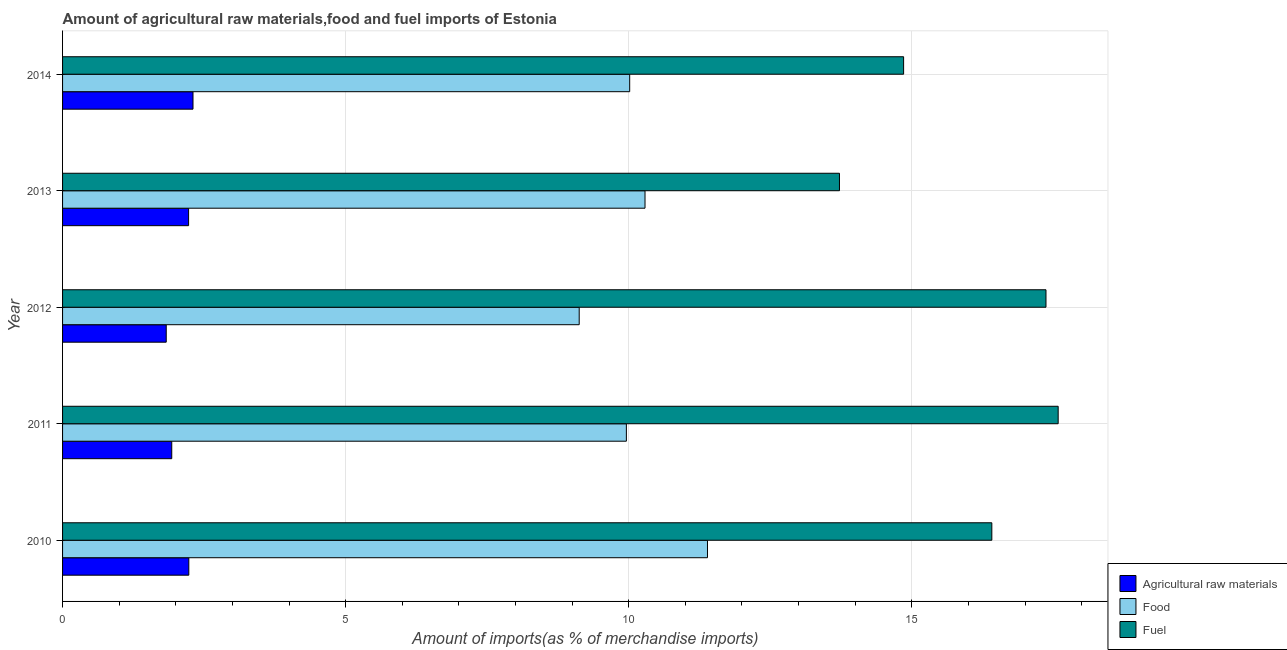Are the number of bars per tick equal to the number of legend labels?
Make the answer very short. Yes. Are the number of bars on each tick of the Y-axis equal?
Ensure brevity in your answer.  Yes. How many bars are there on the 2nd tick from the top?
Provide a short and direct response. 3. How many bars are there on the 5th tick from the bottom?
Your answer should be very brief. 3. What is the label of the 2nd group of bars from the top?
Offer a very short reply. 2013. In how many cases, is the number of bars for a given year not equal to the number of legend labels?
Offer a very short reply. 0. What is the percentage of food imports in 2013?
Your response must be concise. 10.29. Across all years, what is the maximum percentage of raw materials imports?
Give a very brief answer. 2.3. Across all years, what is the minimum percentage of raw materials imports?
Provide a succinct answer. 1.83. In which year was the percentage of fuel imports maximum?
Your response must be concise. 2011. In which year was the percentage of fuel imports minimum?
Ensure brevity in your answer.  2013. What is the total percentage of raw materials imports in the graph?
Keep it short and to the point. 10.52. What is the difference between the percentage of food imports in 2011 and that in 2012?
Your response must be concise. 0.83. What is the difference between the percentage of fuel imports in 2010 and the percentage of food imports in 2013?
Your answer should be compact. 6.13. What is the average percentage of food imports per year?
Give a very brief answer. 10.16. In the year 2011, what is the difference between the percentage of fuel imports and percentage of food imports?
Provide a succinct answer. 7.63. Is the percentage of food imports in 2011 less than that in 2012?
Ensure brevity in your answer.  No. What is the difference between the highest and the second highest percentage of raw materials imports?
Give a very brief answer. 0.07. What is the difference between the highest and the lowest percentage of fuel imports?
Your answer should be very brief. 3.86. In how many years, is the percentage of food imports greater than the average percentage of food imports taken over all years?
Offer a very short reply. 2. What does the 3rd bar from the top in 2014 represents?
Ensure brevity in your answer.  Agricultural raw materials. What does the 2nd bar from the bottom in 2013 represents?
Keep it short and to the point. Food. Is it the case that in every year, the sum of the percentage of raw materials imports and percentage of food imports is greater than the percentage of fuel imports?
Provide a short and direct response. No. How many bars are there?
Your answer should be very brief. 15. Are the values on the major ticks of X-axis written in scientific E-notation?
Give a very brief answer. No. Does the graph contain grids?
Your response must be concise. Yes. How are the legend labels stacked?
Make the answer very short. Vertical. What is the title of the graph?
Make the answer very short. Amount of agricultural raw materials,food and fuel imports of Estonia. What is the label or title of the X-axis?
Offer a very short reply. Amount of imports(as % of merchandise imports). What is the label or title of the Y-axis?
Your response must be concise. Year. What is the Amount of imports(as % of merchandise imports) of Agricultural raw materials in 2010?
Give a very brief answer. 2.23. What is the Amount of imports(as % of merchandise imports) of Food in 2010?
Your answer should be very brief. 11.39. What is the Amount of imports(as % of merchandise imports) in Fuel in 2010?
Make the answer very short. 16.41. What is the Amount of imports(as % of merchandise imports) in Agricultural raw materials in 2011?
Your response must be concise. 1.93. What is the Amount of imports(as % of merchandise imports) of Food in 2011?
Keep it short and to the point. 9.96. What is the Amount of imports(as % of merchandise imports) in Fuel in 2011?
Provide a succinct answer. 17.59. What is the Amount of imports(as % of merchandise imports) in Agricultural raw materials in 2012?
Provide a short and direct response. 1.83. What is the Amount of imports(as % of merchandise imports) of Food in 2012?
Your answer should be very brief. 9.13. What is the Amount of imports(as % of merchandise imports) of Fuel in 2012?
Your answer should be very brief. 17.37. What is the Amount of imports(as % of merchandise imports) of Agricultural raw materials in 2013?
Your response must be concise. 2.23. What is the Amount of imports(as % of merchandise imports) in Food in 2013?
Provide a succinct answer. 10.29. What is the Amount of imports(as % of merchandise imports) of Fuel in 2013?
Keep it short and to the point. 13.72. What is the Amount of imports(as % of merchandise imports) of Agricultural raw materials in 2014?
Provide a succinct answer. 2.3. What is the Amount of imports(as % of merchandise imports) of Food in 2014?
Provide a short and direct response. 10.02. What is the Amount of imports(as % of merchandise imports) in Fuel in 2014?
Your response must be concise. 14.86. Across all years, what is the maximum Amount of imports(as % of merchandise imports) of Agricultural raw materials?
Offer a terse response. 2.3. Across all years, what is the maximum Amount of imports(as % of merchandise imports) in Food?
Offer a terse response. 11.39. Across all years, what is the maximum Amount of imports(as % of merchandise imports) of Fuel?
Make the answer very short. 17.59. Across all years, what is the minimum Amount of imports(as % of merchandise imports) in Agricultural raw materials?
Offer a very short reply. 1.83. Across all years, what is the minimum Amount of imports(as % of merchandise imports) of Food?
Provide a succinct answer. 9.13. Across all years, what is the minimum Amount of imports(as % of merchandise imports) in Fuel?
Provide a short and direct response. 13.72. What is the total Amount of imports(as % of merchandise imports) of Agricultural raw materials in the graph?
Your answer should be very brief. 10.52. What is the total Amount of imports(as % of merchandise imports) of Food in the graph?
Your answer should be very brief. 50.78. What is the total Amount of imports(as % of merchandise imports) of Fuel in the graph?
Your answer should be compact. 79.95. What is the difference between the Amount of imports(as % of merchandise imports) in Agricultural raw materials in 2010 and that in 2011?
Your answer should be compact. 0.3. What is the difference between the Amount of imports(as % of merchandise imports) of Food in 2010 and that in 2011?
Provide a short and direct response. 1.43. What is the difference between the Amount of imports(as % of merchandise imports) in Fuel in 2010 and that in 2011?
Your answer should be compact. -1.17. What is the difference between the Amount of imports(as % of merchandise imports) in Agricultural raw materials in 2010 and that in 2012?
Make the answer very short. 0.4. What is the difference between the Amount of imports(as % of merchandise imports) in Food in 2010 and that in 2012?
Provide a short and direct response. 2.27. What is the difference between the Amount of imports(as % of merchandise imports) in Fuel in 2010 and that in 2012?
Give a very brief answer. -0.96. What is the difference between the Amount of imports(as % of merchandise imports) of Agricultural raw materials in 2010 and that in 2013?
Make the answer very short. 0. What is the difference between the Amount of imports(as % of merchandise imports) of Food in 2010 and that in 2013?
Your answer should be compact. 1.1. What is the difference between the Amount of imports(as % of merchandise imports) in Fuel in 2010 and that in 2013?
Offer a very short reply. 2.69. What is the difference between the Amount of imports(as % of merchandise imports) of Agricultural raw materials in 2010 and that in 2014?
Your answer should be compact. -0.07. What is the difference between the Amount of imports(as % of merchandise imports) of Food in 2010 and that in 2014?
Your answer should be compact. 1.37. What is the difference between the Amount of imports(as % of merchandise imports) of Fuel in 2010 and that in 2014?
Ensure brevity in your answer.  1.56. What is the difference between the Amount of imports(as % of merchandise imports) in Agricultural raw materials in 2011 and that in 2012?
Provide a succinct answer. 0.1. What is the difference between the Amount of imports(as % of merchandise imports) of Food in 2011 and that in 2012?
Make the answer very short. 0.83. What is the difference between the Amount of imports(as % of merchandise imports) in Fuel in 2011 and that in 2012?
Make the answer very short. 0.22. What is the difference between the Amount of imports(as % of merchandise imports) in Agricultural raw materials in 2011 and that in 2013?
Offer a very short reply. -0.3. What is the difference between the Amount of imports(as % of merchandise imports) in Food in 2011 and that in 2013?
Give a very brief answer. -0.33. What is the difference between the Amount of imports(as % of merchandise imports) in Fuel in 2011 and that in 2013?
Your answer should be compact. 3.86. What is the difference between the Amount of imports(as % of merchandise imports) in Agricultural raw materials in 2011 and that in 2014?
Provide a short and direct response. -0.38. What is the difference between the Amount of imports(as % of merchandise imports) of Food in 2011 and that in 2014?
Your answer should be compact. -0.06. What is the difference between the Amount of imports(as % of merchandise imports) in Fuel in 2011 and that in 2014?
Provide a succinct answer. 2.73. What is the difference between the Amount of imports(as % of merchandise imports) in Agricultural raw materials in 2012 and that in 2013?
Your answer should be compact. -0.39. What is the difference between the Amount of imports(as % of merchandise imports) in Food in 2012 and that in 2013?
Provide a succinct answer. -1.16. What is the difference between the Amount of imports(as % of merchandise imports) in Fuel in 2012 and that in 2013?
Give a very brief answer. 3.65. What is the difference between the Amount of imports(as % of merchandise imports) of Agricultural raw materials in 2012 and that in 2014?
Your response must be concise. -0.47. What is the difference between the Amount of imports(as % of merchandise imports) of Food in 2012 and that in 2014?
Keep it short and to the point. -0.89. What is the difference between the Amount of imports(as % of merchandise imports) in Fuel in 2012 and that in 2014?
Your response must be concise. 2.51. What is the difference between the Amount of imports(as % of merchandise imports) of Agricultural raw materials in 2013 and that in 2014?
Your response must be concise. -0.08. What is the difference between the Amount of imports(as % of merchandise imports) in Food in 2013 and that in 2014?
Your answer should be compact. 0.27. What is the difference between the Amount of imports(as % of merchandise imports) in Fuel in 2013 and that in 2014?
Your answer should be very brief. -1.13. What is the difference between the Amount of imports(as % of merchandise imports) of Agricultural raw materials in 2010 and the Amount of imports(as % of merchandise imports) of Food in 2011?
Keep it short and to the point. -7.73. What is the difference between the Amount of imports(as % of merchandise imports) of Agricultural raw materials in 2010 and the Amount of imports(as % of merchandise imports) of Fuel in 2011?
Ensure brevity in your answer.  -15.36. What is the difference between the Amount of imports(as % of merchandise imports) of Food in 2010 and the Amount of imports(as % of merchandise imports) of Fuel in 2011?
Provide a short and direct response. -6.19. What is the difference between the Amount of imports(as % of merchandise imports) in Agricultural raw materials in 2010 and the Amount of imports(as % of merchandise imports) in Food in 2012?
Ensure brevity in your answer.  -6.9. What is the difference between the Amount of imports(as % of merchandise imports) of Agricultural raw materials in 2010 and the Amount of imports(as % of merchandise imports) of Fuel in 2012?
Offer a terse response. -15.14. What is the difference between the Amount of imports(as % of merchandise imports) in Food in 2010 and the Amount of imports(as % of merchandise imports) in Fuel in 2012?
Your response must be concise. -5.98. What is the difference between the Amount of imports(as % of merchandise imports) of Agricultural raw materials in 2010 and the Amount of imports(as % of merchandise imports) of Food in 2013?
Your answer should be very brief. -8.06. What is the difference between the Amount of imports(as % of merchandise imports) of Agricultural raw materials in 2010 and the Amount of imports(as % of merchandise imports) of Fuel in 2013?
Your response must be concise. -11.49. What is the difference between the Amount of imports(as % of merchandise imports) of Food in 2010 and the Amount of imports(as % of merchandise imports) of Fuel in 2013?
Ensure brevity in your answer.  -2.33. What is the difference between the Amount of imports(as % of merchandise imports) of Agricultural raw materials in 2010 and the Amount of imports(as % of merchandise imports) of Food in 2014?
Your response must be concise. -7.79. What is the difference between the Amount of imports(as % of merchandise imports) of Agricultural raw materials in 2010 and the Amount of imports(as % of merchandise imports) of Fuel in 2014?
Offer a terse response. -12.63. What is the difference between the Amount of imports(as % of merchandise imports) in Food in 2010 and the Amount of imports(as % of merchandise imports) in Fuel in 2014?
Make the answer very short. -3.46. What is the difference between the Amount of imports(as % of merchandise imports) in Agricultural raw materials in 2011 and the Amount of imports(as % of merchandise imports) in Food in 2012?
Make the answer very short. -7.2. What is the difference between the Amount of imports(as % of merchandise imports) of Agricultural raw materials in 2011 and the Amount of imports(as % of merchandise imports) of Fuel in 2012?
Give a very brief answer. -15.44. What is the difference between the Amount of imports(as % of merchandise imports) of Food in 2011 and the Amount of imports(as % of merchandise imports) of Fuel in 2012?
Offer a terse response. -7.41. What is the difference between the Amount of imports(as % of merchandise imports) of Agricultural raw materials in 2011 and the Amount of imports(as % of merchandise imports) of Food in 2013?
Provide a short and direct response. -8.36. What is the difference between the Amount of imports(as % of merchandise imports) of Agricultural raw materials in 2011 and the Amount of imports(as % of merchandise imports) of Fuel in 2013?
Make the answer very short. -11.79. What is the difference between the Amount of imports(as % of merchandise imports) in Food in 2011 and the Amount of imports(as % of merchandise imports) in Fuel in 2013?
Offer a very short reply. -3.76. What is the difference between the Amount of imports(as % of merchandise imports) in Agricultural raw materials in 2011 and the Amount of imports(as % of merchandise imports) in Food in 2014?
Your response must be concise. -8.09. What is the difference between the Amount of imports(as % of merchandise imports) in Agricultural raw materials in 2011 and the Amount of imports(as % of merchandise imports) in Fuel in 2014?
Your response must be concise. -12.93. What is the difference between the Amount of imports(as % of merchandise imports) in Food in 2011 and the Amount of imports(as % of merchandise imports) in Fuel in 2014?
Provide a succinct answer. -4.9. What is the difference between the Amount of imports(as % of merchandise imports) in Agricultural raw materials in 2012 and the Amount of imports(as % of merchandise imports) in Food in 2013?
Offer a terse response. -8.46. What is the difference between the Amount of imports(as % of merchandise imports) in Agricultural raw materials in 2012 and the Amount of imports(as % of merchandise imports) in Fuel in 2013?
Give a very brief answer. -11.89. What is the difference between the Amount of imports(as % of merchandise imports) in Food in 2012 and the Amount of imports(as % of merchandise imports) in Fuel in 2013?
Provide a succinct answer. -4.6. What is the difference between the Amount of imports(as % of merchandise imports) in Agricultural raw materials in 2012 and the Amount of imports(as % of merchandise imports) in Food in 2014?
Offer a very short reply. -8.19. What is the difference between the Amount of imports(as % of merchandise imports) in Agricultural raw materials in 2012 and the Amount of imports(as % of merchandise imports) in Fuel in 2014?
Make the answer very short. -13.02. What is the difference between the Amount of imports(as % of merchandise imports) in Food in 2012 and the Amount of imports(as % of merchandise imports) in Fuel in 2014?
Keep it short and to the point. -5.73. What is the difference between the Amount of imports(as % of merchandise imports) of Agricultural raw materials in 2013 and the Amount of imports(as % of merchandise imports) of Food in 2014?
Ensure brevity in your answer.  -7.79. What is the difference between the Amount of imports(as % of merchandise imports) of Agricultural raw materials in 2013 and the Amount of imports(as % of merchandise imports) of Fuel in 2014?
Your response must be concise. -12.63. What is the difference between the Amount of imports(as % of merchandise imports) in Food in 2013 and the Amount of imports(as % of merchandise imports) in Fuel in 2014?
Provide a short and direct response. -4.57. What is the average Amount of imports(as % of merchandise imports) of Agricultural raw materials per year?
Make the answer very short. 2.1. What is the average Amount of imports(as % of merchandise imports) of Food per year?
Make the answer very short. 10.16. What is the average Amount of imports(as % of merchandise imports) of Fuel per year?
Provide a short and direct response. 15.99. In the year 2010, what is the difference between the Amount of imports(as % of merchandise imports) in Agricultural raw materials and Amount of imports(as % of merchandise imports) in Food?
Ensure brevity in your answer.  -9.16. In the year 2010, what is the difference between the Amount of imports(as % of merchandise imports) of Agricultural raw materials and Amount of imports(as % of merchandise imports) of Fuel?
Provide a succinct answer. -14.18. In the year 2010, what is the difference between the Amount of imports(as % of merchandise imports) of Food and Amount of imports(as % of merchandise imports) of Fuel?
Your answer should be compact. -5.02. In the year 2011, what is the difference between the Amount of imports(as % of merchandise imports) of Agricultural raw materials and Amount of imports(as % of merchandise imports) of Food?
Keep it short and to the point. -8.03. In the year 2011, what is the difference between the Amount of imports(as % of merchandise imports) of Agricultural raw materials and Amount of imports(as % of merchandise imports) of Fuel?
Give a very brief answer. -15.66. In the year 2011, what is the difference between the Amount of imports(as % of merchandise imports) of Food and Amount of imports(as % of merchandise imports) of Fuel?
Ensure brevity in your answer.  -7.63. In the year 2012, what is the difference between the Amount of imports(as % of merchandise imports) in Agricultural raw materials and Amount of imports(as % of merchandise imports) in Food?
Your answer should be compact. -7.29. In the year 2012, what is the difference between the Amount of imports(as % of merchandise imports) of Agricultural raw materials and Amount of imports(as % of merchandise imports) of Fuel?
Your answer should be compact. -15.54. In the year 2012, what is the difference between the Amount of imports(as % of merchandise imports) in Food and Amount of imports(as % of merchandise imports) in Fuel?
Provide a short and direct response. -8.24. In the year 2013, what is the difference between the Amount of imports(as % of merchandise imports) of Agricultural raw materials and Amount of imports(as % of merchandise imports) of Food?
Give a very brief answer. -8.06. In the year 2013, what is the difference between the Amount of imports(as % of merchandise imports) of Agricultural raw materials and Amount of imports(as % of merchandise imports) of Fuel?
Offer a very short reply. -11.5. In the year 2013, what is the difference between the Amount of imports(as % of merchandise imports) in Food and Amount of imports(as % of merchandise imports) in Fuel?
Give a very brief answer. -3.43. In the year 2014, what is the difference between the Amount of imports(as % of merchandise imports) of Agricultural raw materials and Amount of imports(as % of merchandise imports) of Food?
Your response must be concise. -7.71. In the year 2014, what is the difference between the Amount of imports(as % of merchandise imports) of Agricultural raw materials and Amount of imports(as % of merchandise imports) of Fuel?
Keep it short and to the point. -12.55. In the year 2014, what is the difference between the Amount of imports(as % of merchandise imports) in Food and Amount of imports(as % of merchandise imports) in Fuel?
Your response must be concise. -4.84. What is the ratio of the Amount of imports(as % of merchandise imports) in Agricultural raw materials in 2010 to that in 2011?
Offer a terse response. 1.16. What is the ratio of the Amount of imports(as % of merchandise imports) of Food in 2010 to that in 2011?
Give a very brief answer. 1.14. What is the ratio of the Amount of imports(as % of merchandise imports) in Fuel in 2010 to that in 2011?
Provide a short and direct response. 0.93. What is the ratio of the Amount of imports(as % of merchandise imports) in Agricultural raw materials in 2010 to that in 2012?
Make the answer very short. 1.22. What is the ratio of the Amount of imports(as % of merchandise imports) of Food in 2010 to that in 2012?
Offer a very short reply. 1.25. What is the ratio of the Amount of imports(as % of merchandise imports) in Fuel in 2010 to that in 2012?
Provide a succinct answer. 0.94. What is the ratio of the Amount of imports(as % of merchandise imports) in Food in 2010 to that in 2013?
Your answer should be compact. 1.11. What is the ratio of the Amount of imports(as % of merchandise imports) in Fuel in 2010 to that in 2013?
Give a very brief answer. 1.2. What is the ratio of the Amount of imports(as % of merchandise imports) of Food in 2010 to that in 2014?
Provide a succinct answer. 1.14. What is the ratio of the Amount of imports(as % of merchandise imports) of Fuel in 2010 to that in 2014?
Give a very brief answer. 1.1. What is the ratio of the Amount of imports(as % of merchandise imports) of Agricultural raw materials in 2011 to that in 2012?
Make the answer very short. 1.05. What is the ratio of the Amount of imports(as % of merchandise imports) of Food in 2011 to that in 2012?
Ensure brevity in your answer.  1.09. What is the ratio of the Amount of imports(as % of merchandise imports) of Fuel in 2011 to that in 2012?
Give a very brief answer. 1.01. What is the ratio of the Amount of imports(as % of merchandise imports) in Agricultural raw materials in 2011 to that in 2013?
Offer a very short reply. 0.87. What is the ratio of the Amount of imports(as % of merchandise imports) of Food in 2011 to that in 2013?
Offer a very short reply. 0.97. What is the ratio of the Amount of imports(as % of merchandise imports) in Fuel in 2011 to that in 2013?
Keep it short and to the point. 1.28. What is the ratio of the Amount of imports(as % of merchandise imports) in Agricultural raw materials in 2011 to that in 2014?
Keep it short and to the point. 0.84. What is the ratio of the Amount of imports(as % of merchandise imports) in Food in 2011 to that in 2014?
Give a very brief answer. 0.99. What is the ratio of the Amount of imports(as % of merchandise imports) in Fuel in 2011 to that in 2014?
Keep it short and to the point. 1.18. What is the ratio of the Amount of imports(as % of merchandise imports) in Agricultural raw materials in 2012 to that in 2013?
Provide a succinct answer. 0.82. What is the ratio of the Amount of imports(as % of merchandise imports) of Food in 2012 to that in 2013?
Give a very brief answer. 0.89. What is the ratio of the Amount of imports(as % of merchandise imports) in Fuel in 2012 to that in 2013?
Offer a terse response. 1.27. What is the ratio of the Amount of imports(as % of merchandise imports) in Agricultural raw materials in 2012 to that in 2014?
Provide a short and direct response. 0.79. What is the ratio of the Amount of imports(as % of merchandise imports) of Food in 2012 to that in 2014?
Provide a short and direct response. 0.91. What is the ratio of the Amount of imports(as % of merchandise imports) in Fuel in 2012 to that in 2014?
Your answer should be very brief. 1.17. What is the ratio of the Amount of imports(as % of merchandise imports) in Agricultural raw materials in 2013 to that in 2014?
Keep it short and to the point. 0.97. What is the ratio of the Amount of imports(as % of merchandise imports) of Fuel in 2013 to that in 2014?
Offer a very short reply. 0.92. What is the difference between the highest and the second highest Amount of imports(as % of merchandise imports) of Agricultural raw materials?
Your response must be concise. 0.07. What is the difference between the highest and the second highest Amount of imports(as % of merchandise imports) of Food?
Your answer should be very brief. 1.1. What is the difference between the highest and the second highest Amount of imports(as % of merchandise imports) in Fuel?
Provide a succinct answer. 0.22. What is the difference between the highest and the lowest Amount of imports(as % of merchandise imports) in Agricultural raw materials?
Your answer should be very brief. 0.47. What is the difference between the highest and the lowest Amount of imports(as % of merchandise imports) of Food?
Your answer should be compact. 2.27. What is the difference between the highest and the lowest Amount of imports(as % of merchandise imports) in Fuel?
Your response must be concise. 3.86. 